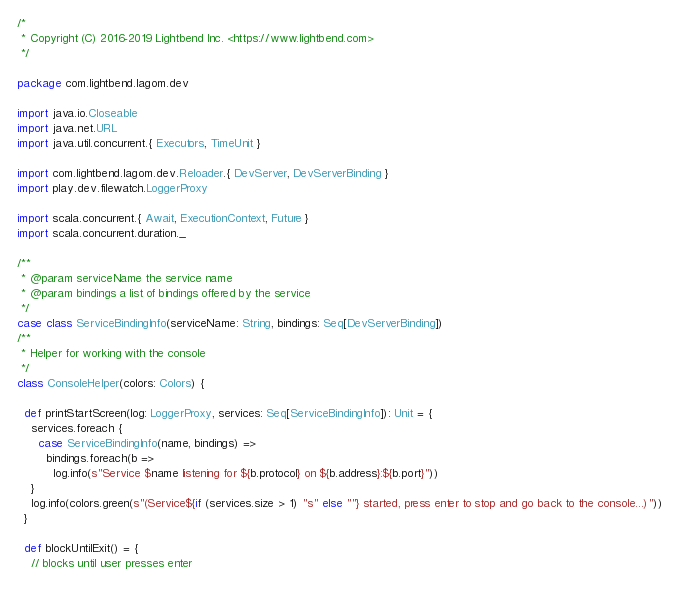Convert code to text. <code><loc_0><loc_0><loc_500><loc_500><_Scala_>/*
 * Copyright (C) 2016-2019 Lightbend Inc. <https://www.lightbend.com>
 */

package com.lightbend.lagom.dev

import java.io.Closeable
import java.net.URL
import java.util.concurrent.{ Executors, TimeUnit }

import com.lightbend.lagom.dev.Reloader.{ DevServer, DevServerBinding }
import play.dev.filewatch.LoggerProxy

import scala.concurrent.{ Await, ExecutionContext, Future }
import scala.concurrent.duration._

/**
 * @param serviceName the service name
 * @param bindings a list of bindings offered by the service
 */
case class ServiceBindingInfo(serviceName: String, bindings: Seq[DevServerBinding])
/**
 * Helper for working with the console
 */
class ConsoleHelper(colors: Colors) {

  def printStartScreen(log: LoggerProxy, services: Seq[ServiceBindingInfo]): Unit = {
    services.foreach {
      case ServiceBindingInfo(name, bindings) =>
        bindings.foreach(b =>
          log.info(s"Service $name listening for ${b.protocol} on ${b.address}:${b.port}"))
    }
    log.info(colors.green(s"(Service${if (services.size > 1) "s" else ""} started, press enter to stop and go back to the console...)"))
  }

  def blockUntilExit() = {
    // blocks until user presses enter</code> 